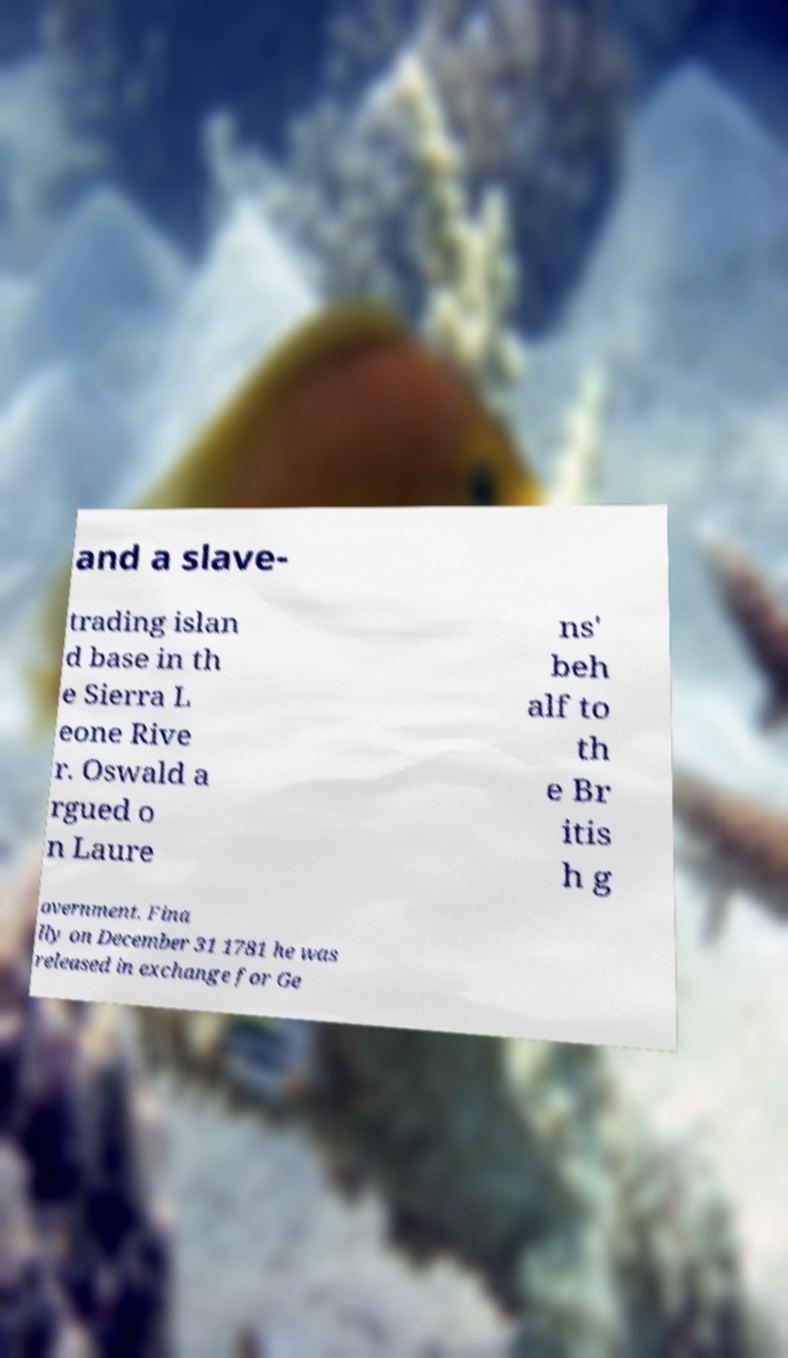There's text embedded in this image that I need extracted. Can you transcribe it verbatim? and a slave- trading islan d base in th e Sierra L eone Rive r. Oswald a rgued o n Laure ns' beh alf to th e Br itis h g overnment. Fina lly on December 31 1781 he was released in exchange for Ge 